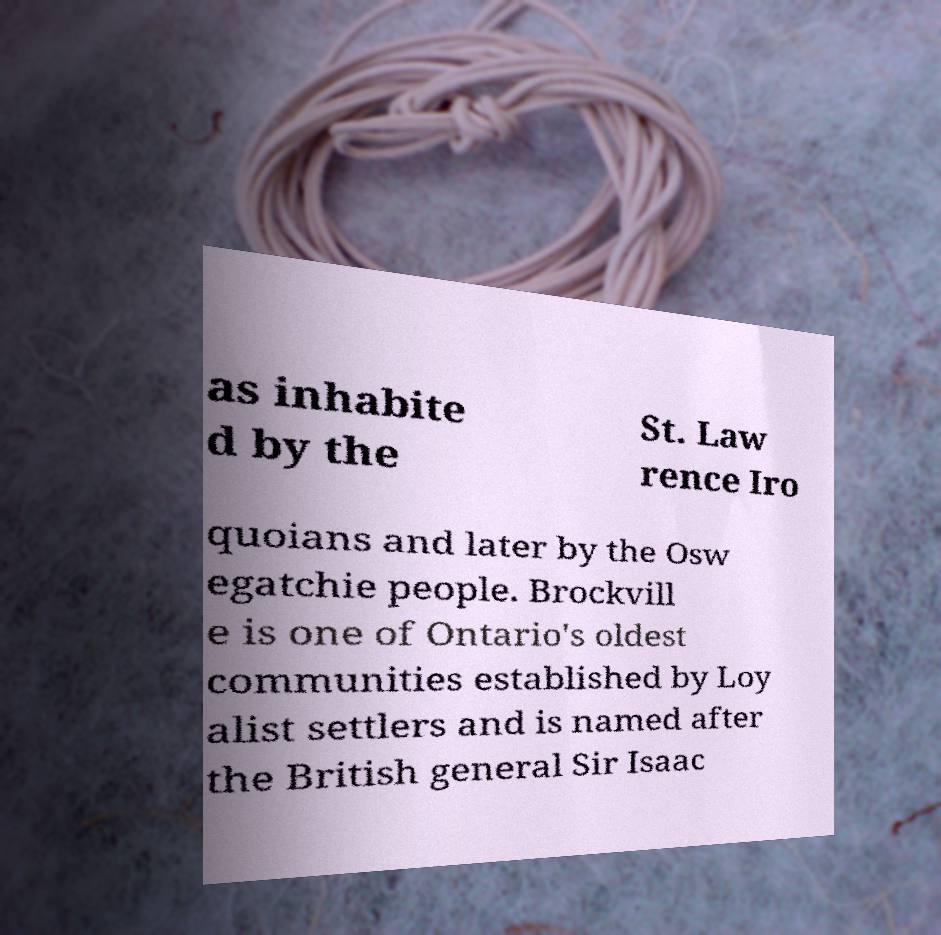Please read and relay the text visible in this image. What does it say? as inhabite d by the St. Law rence Iro quoians and later by the Osw egatchie people. Brockvill e is one of Ontario's oldest communities established by Loy alist settlers and is named after the British general Sir Isaac 